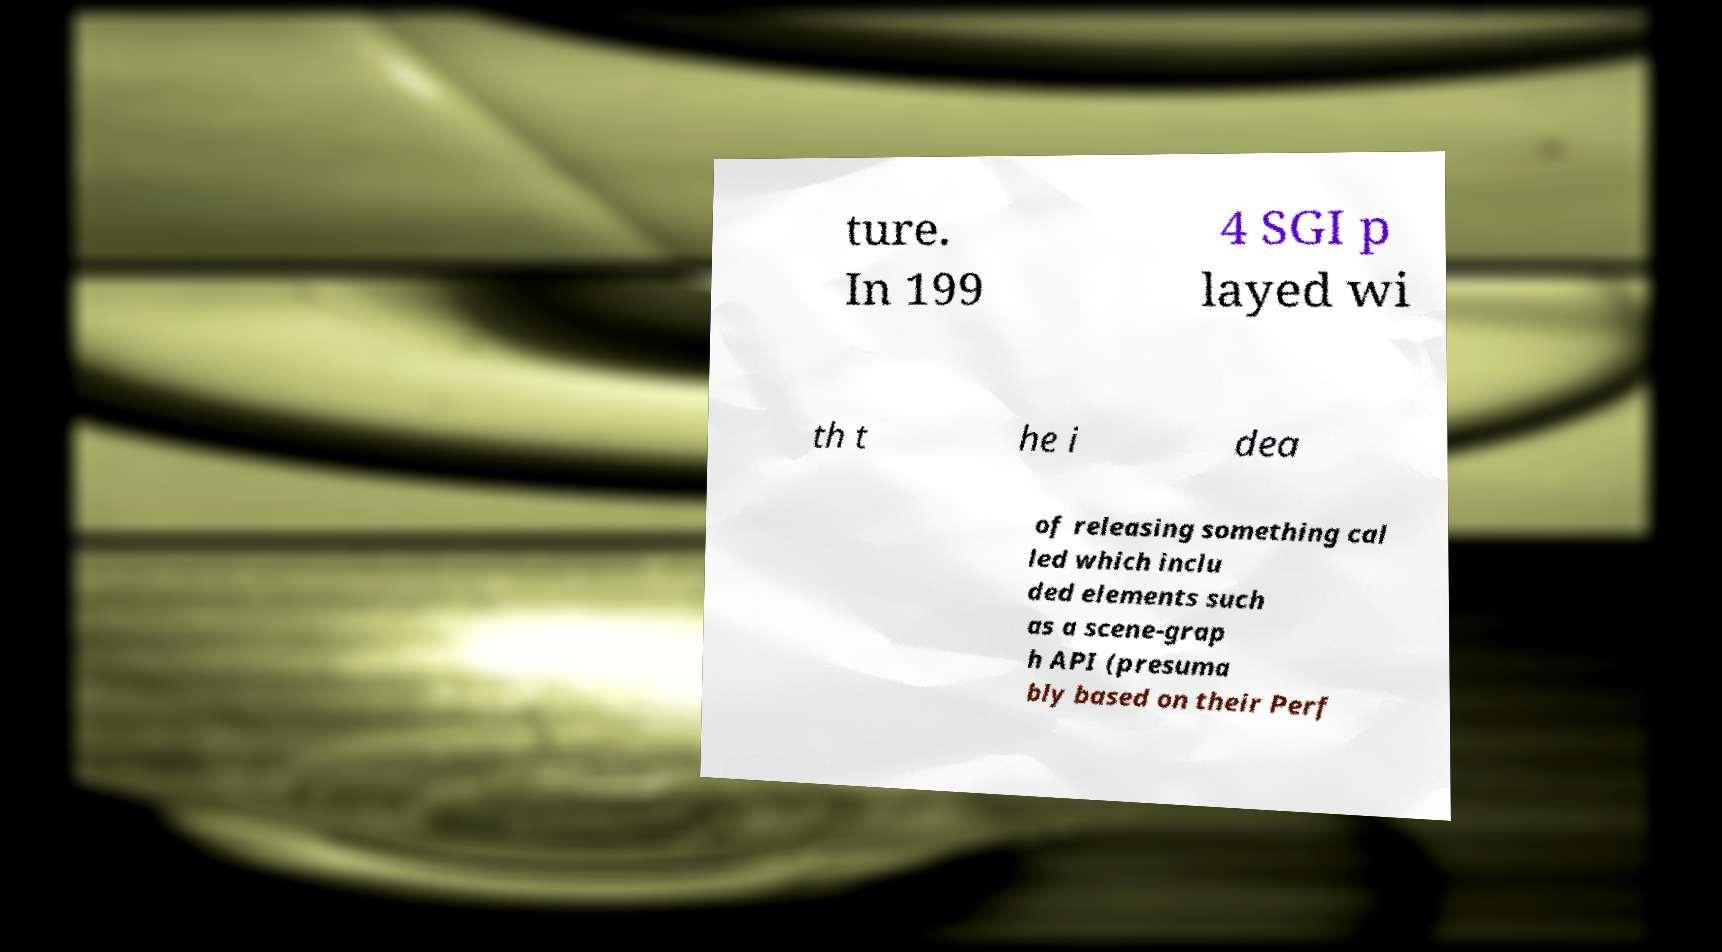I need the written content from this picture converted into text. Can you do that? ture. In 199 4 SGI p layed wi th t he i dea of releasing something cal led which inclu ded elements such as a scene-grap h API (presuma bly based on their Perf 